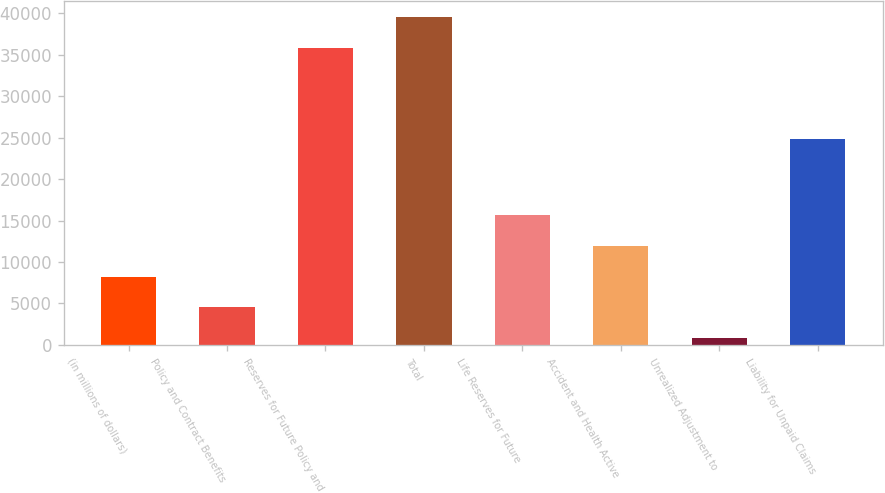Convert chart. <chart><loc_0><loc_0><loc_500><loc_500><bar_chart><fcel>(in millions of dollars)<fcel>Policy and Contract Benefits<fcel>Reserves for Future Policy and<fcel>Total<fcel>Life Reserves for Future<fcel>Accident and Health Active<fcel>Unrealized Adjustment to<fcel>Liability for Unpaid Claims<nl><fcel>8248.98<fcel>4554.14<fcel>35828<fcel>39522.8<fcel>15638.7<fcel>11943.8<fcel>859.3<fcel>24790<nl></chart> 